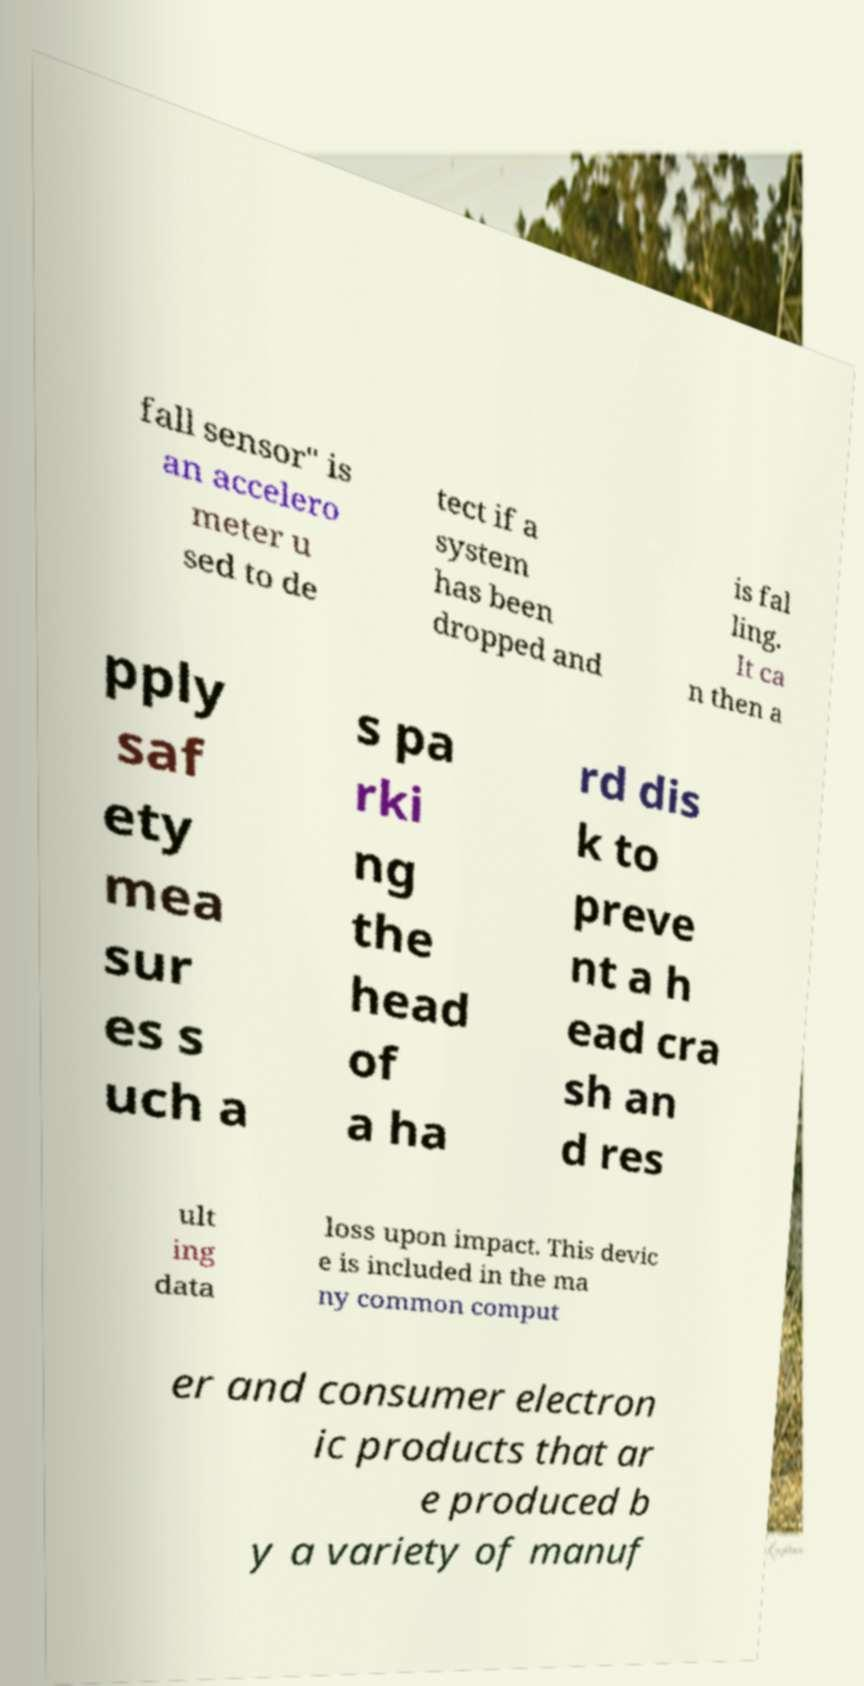There's text embedded in this image that I need extracted. Can you transcribe it verbatim? fall sensor" is an accelero meter u sed to de tect if a system has been dropped and is fal ling. It ca n then a pply saf ety mea sur es s uch a s pa rki ng the head of a ha rd dis k to preve nt a h ead cra sh an d res ult ing data loss upon impact. This devic e is included in the ma ny common comput er and consumer electron ic products that ar e produced b y a variety of manuf 